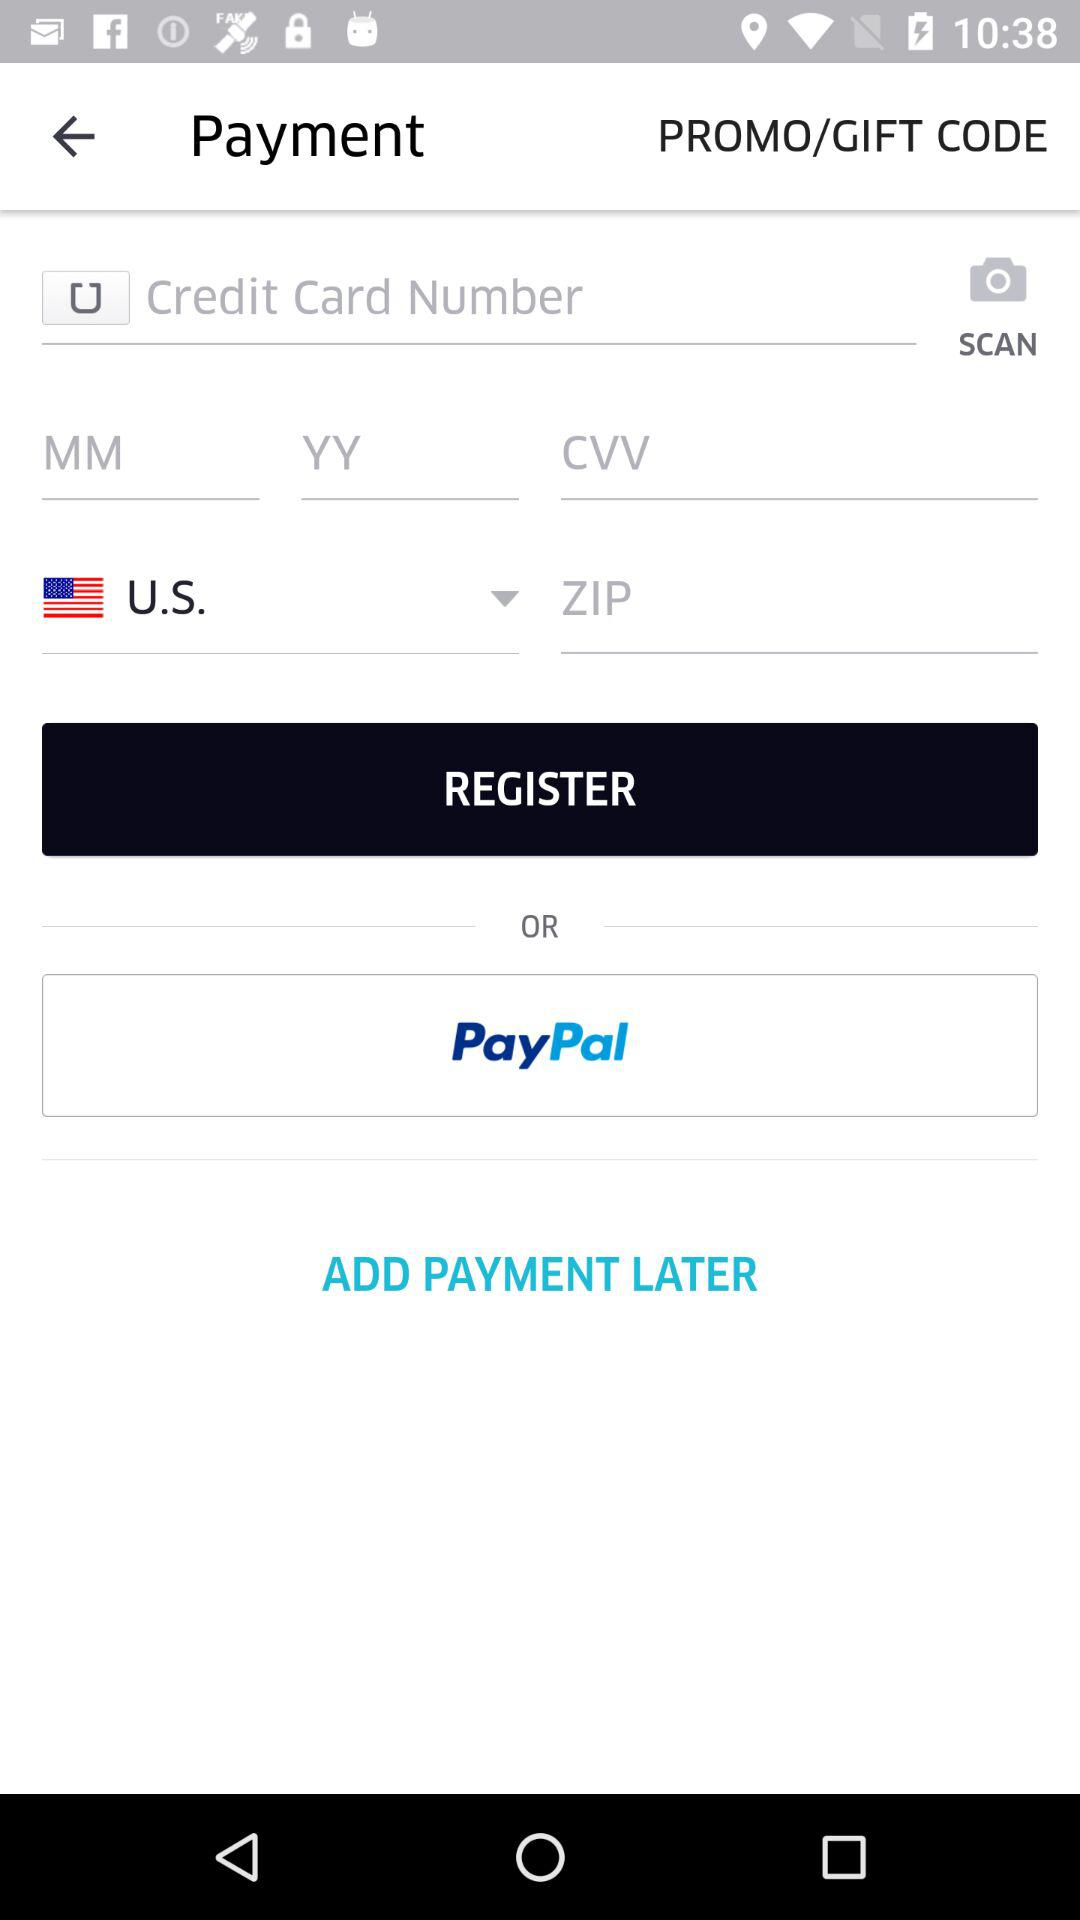What is the selected country? The selected country is the US. 